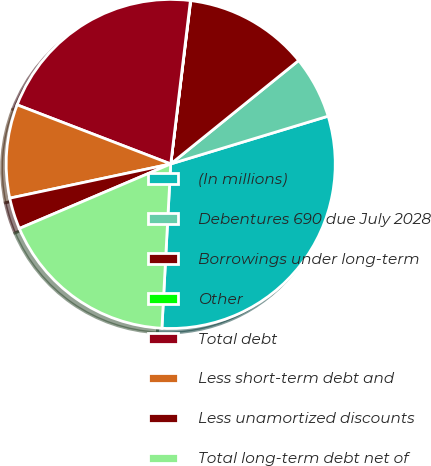Convert chart. <chart><loc_0><loc_0><loc_500><loc_500><pie_chart><fcel>(In millions)<fcel>Debentures 690 due July 2028<fcel>Borrowings under long-term<fcel>Other<fcel>Total debt<fcel>Less short-term debt and<fcel>Less unamortized discounts<fcel>Total long-term debt net of<nl><fcel>30.54%<fcel>6.13%<fcel>12.24%<fcel>0.03%<fcel>21.06%<fcel>9.18%<fcel>3.08%<fcel>17.73%<nl></chart> 